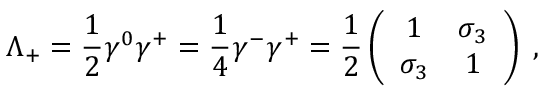<formula> <loc_0><loc_0><loc_500><loc_500>\Lambda _ { + } = { \frac { 1 } { 2 } } \gamma ^ { 0 } \gamma ^ { + } = { \frac { 1 } { 4 } } \gamma ^ { - } \gamma ^ { + } = { \frac { 1 } { 2 } } \left ( \begin{array} { c c } { 1 } & { { \sigma _ { 3 } } } \\ { { \sigma _ { 3 } } } & { 1 } \end{array} \right ) \, ,</formula> 